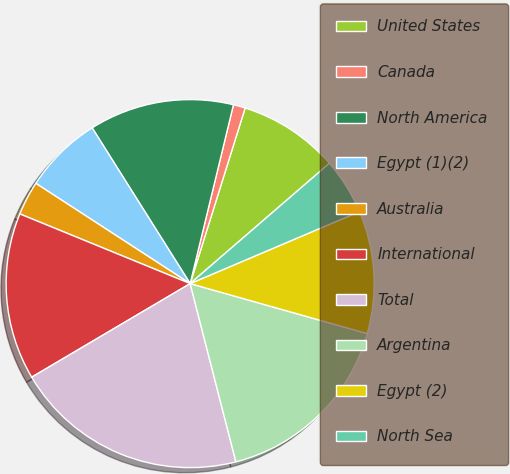Convert chart to OTSL. <chart><loc_0><loc_0><loc_500><loc_500><pie_chart><fcel>United States<fcel>Canada<fcel>North America<fcel>Egypt (1)(2)<fcel>Australia<fcel>International<fcel>Total<fcel>Argentina<fcel>Egypt (2)<fcel>North Sea<nl><fcel>8.83%<fcel>1.05%<fcel>12.72%<fcel>6.89%<fcel>2.99%<fcel>14.67%<fcel>20.51%<fcel>16.62%<fcel>10.78%<fcel>4.94%<nl></chart> 